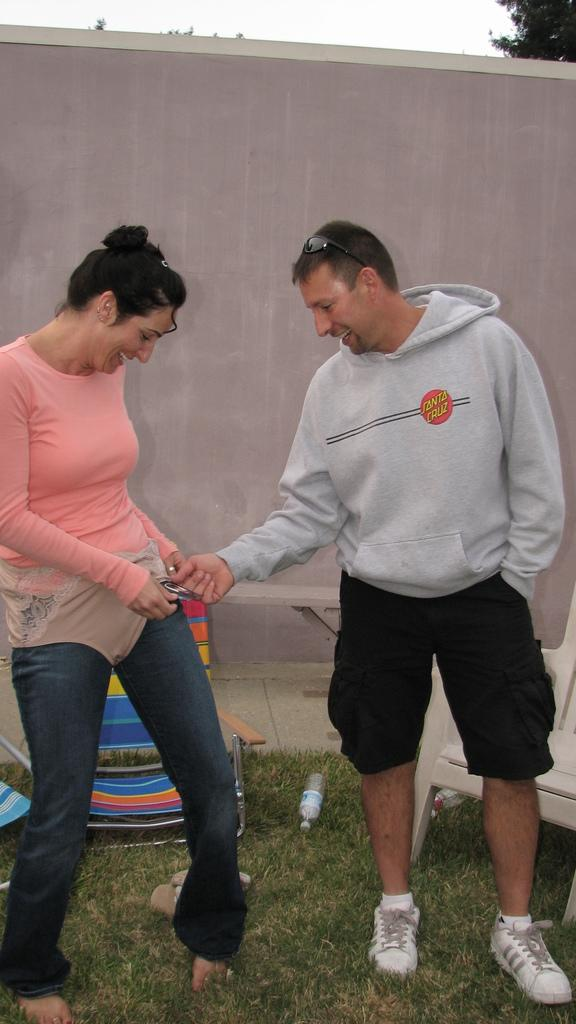How many people are present in the image? There are two people, a man and a woman, present in the image. What are the man and woman doing in the image? Both the man and woman are standing on the ground. What can be seen in the background of the image? There is a bottle, chairs, a wall, trees, and the sky visible in the background of the image. What type of care does the crow require in the image? There is no crow present in the image, so it is not possible to determine what type of care it might require. 